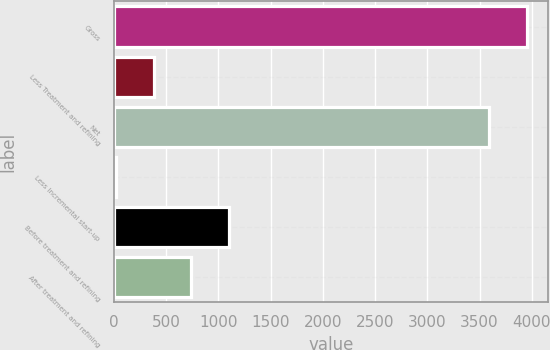Convert chart to OTSL. <chart><loc_0><loc_0><loc_500><loc_500><bar_chart><fcel>Gross<fcel>Less Treatment and refining<fcel>Net<fcel>Less Incremental start-up<fcel>Before treatment and refining<fcel>After treatment and refining<nl><fcel>3952.7<fcel>381.7<fcel>3593<fcel>22<fcel>1101.1<fcel>741.4<nl></chart> 